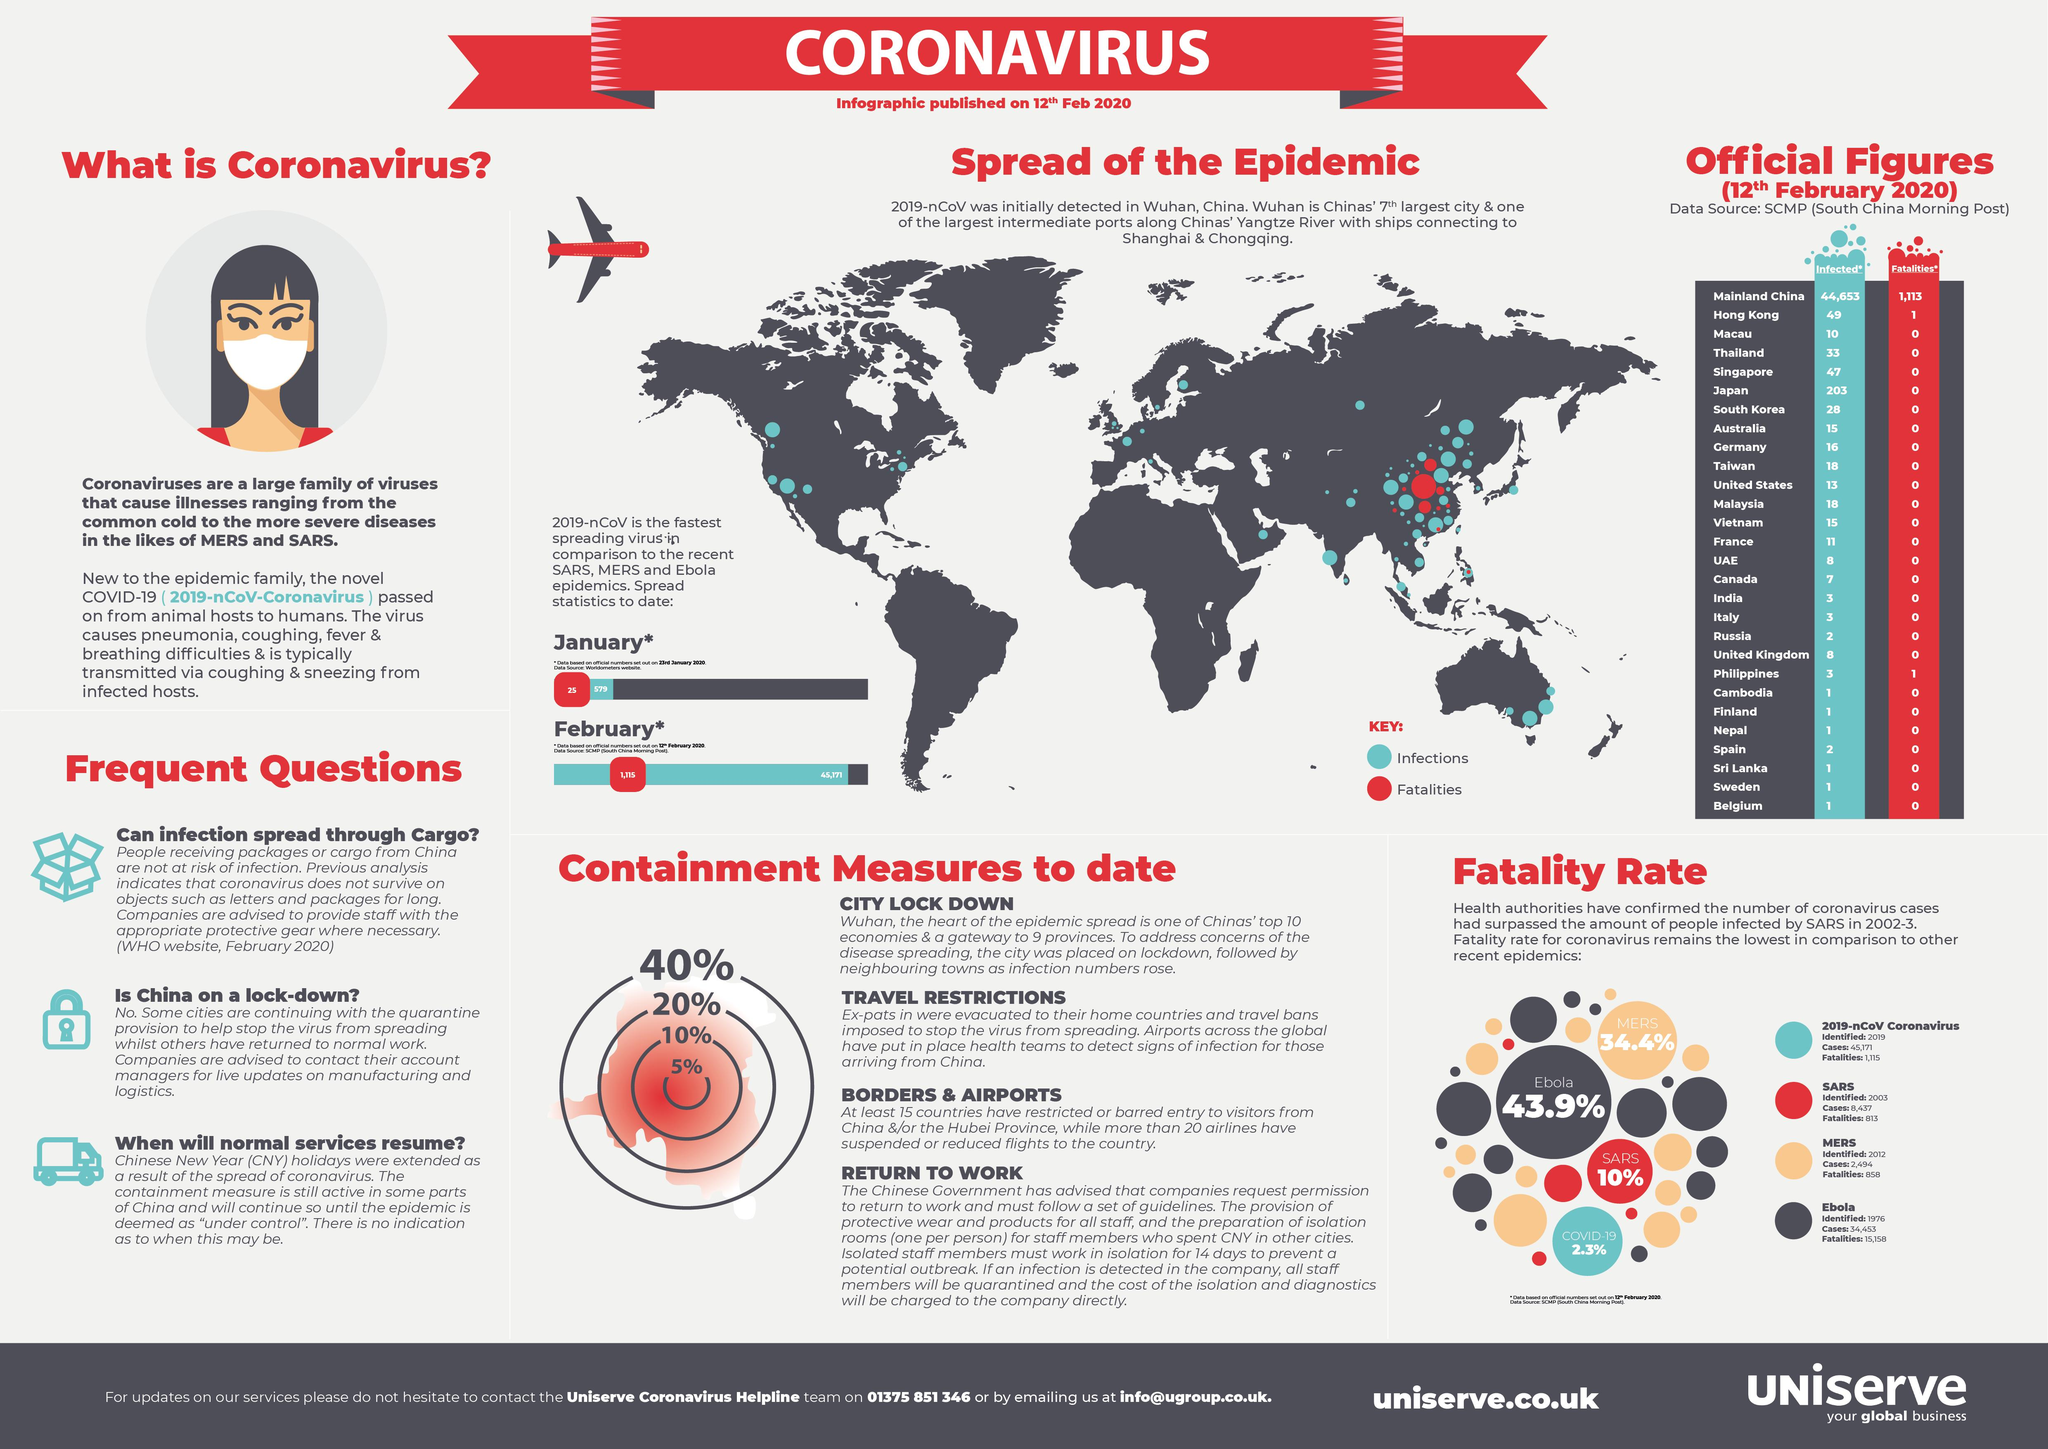Point out several critical features in this image. As of February 12, 2020, the number of reported Covid-19 deaths in Hong Kong was 1. As of February 12, 2020, mainland China has reported the highest fatality rate due to Covid-19. The Ebola virus was first discovered in 1976. As of February 12, 2020, the total number of COVID-19 cases reported in Japan was 203. As of February 12, 2020, the fatality rate due to the Ebola virus is 43.9%. 